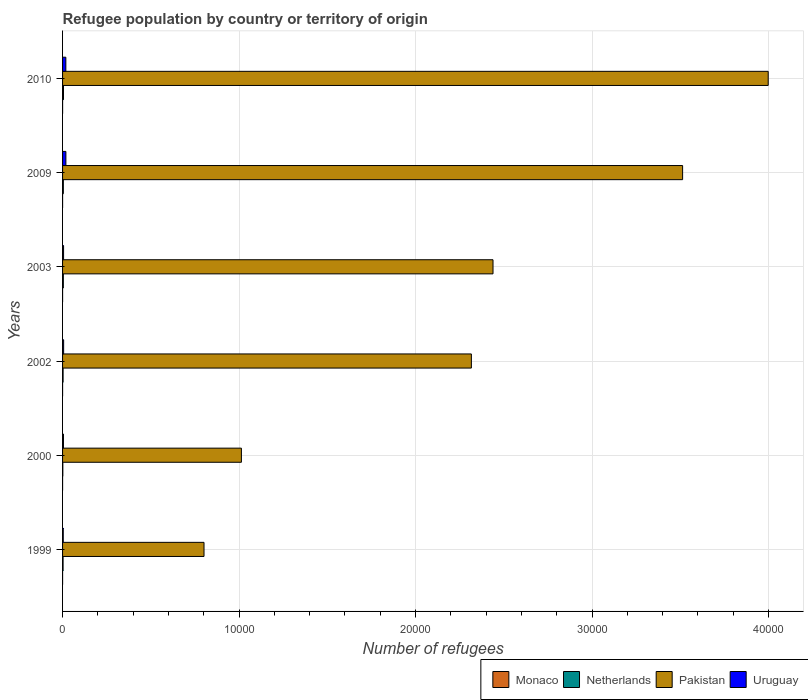How many different coloured bars are there?
Your response must be concise. 4. Are the number of bars per tick equal to the number of legend labels?
Offer a terse response. Yes. How many bars are there on the 6th tick from the top?
Provide a short and direct response. 4. What is the label of the 5th group of bars from the top?
Provide a succinct answer. 2000. What is the number of refugees in Uruguay in 2000?
Give a very brief answer. 51. Across all years, what is the minimum number of refugees in Monaco?
Provide a succinct answer. 1. In which year was the number of refugees in Pakistan maximum?
Ensure brevity in your answer.  2010. What is the difference between the number of refugees in Monaco in 1999 and that in 2000?
Keep it short and to the point. 0. What is the difference between the number of refugees in Monaco in 2000 and the number of refugees in Uruguay in 1999?
Keep it short and to the point. -38. What is the average number of refugees in Uruguay per year?
Offer a terse response. 97. In the year 2010, what is the difference between the number of refugees in Monaco and number of refugees in Netherlands?
Keep it short and to the point. -51. In how many years, is the number of refugees in Monaco greater than 18000 ?
Provide a short and direct response. 0. Is the difference between the number of refugees in Monaco in 2002 and 2009 greater than the difference between the number of refugees in Netherlands in 2002 and 2009?
Provide a succinct answer. Yes. What is the difference between the highest and the second highest number of refugees in Monaco?
Keep it short and to the point. 1. What is the difference between the highest and the lowest number of refugees in Uruguay?
Your answer should be very brief. 149. What does the 1st bar from the bottom in 2000 represents?
Your response must be concise. Monaco. Is it the case that in every year, the sum of the number of refugees in Monaco and number of refugees in Netherlands is greater than the number of refugees in Pakistan?
Your response must be concise. No. How many bars are there?
Make the answer very short. 24. Are the values on the major ticks of X-axis written in scientific E-notation?
Your answer should be very brief. No. Does the graph contain any zero values?
Your answer should be compact. No. Does the graph contain grids?
Keep it short and to the point. Yes. Where does the legend appear in the graph?
Ensure brevity in your answer.  Bottom right. How many legend labels are there?
Make the answer very short. 4. What is the title of the graph?
Your answer should be compact. Refugee population by country or territory of origin. Does "Jordan" appear as one of the legend labels in the graph?
Offer a very short reply. No. What is the label or title of the X-axis?
Offer a very short reply. Number of refugees. What is the Number of refugees in Netherlands in 1999?
Offer a very short reply. 29. What is the Number of refugees in Pakistan in 1999?
Make the answer very short. 8015. What is the Number of refugees in Netherlands in 2000?
Keep it short and to the point. 15. What is the Number of refugees of Pakistan in 2000?
Make the answer very short. 1.01e+04. What is the Number of refugees of Monaco in 2002?
Your answer should be very brief. 1. What is the Number of refugees in Netherlands in 2002?
Provide a succinct answer. 30. What is the Number of refugees in Pakistan in 2002?
Your response must be concise. 2.32e+04. What is the Number of refugees of Uruguay in 2002?
Your response must be concise. 61. What is the Number of refugees of Monaco in 2003?
Offer a terse response. 1. What is the Number of refugees of Pakistan in 2003?
Provide a succinct answer. 2.44e+04. What is the Number of refugees in Uruguay in 2003?
Ensure brevity in your answer.  57. What is the Number of refugees in Netherlands in 2009?
Make the answer very short. 44. What is the Number of refugees of Pakistan in 2009?
Your answer should be very brief. 3.51e+04. What is the Number of refugees in Uruguay in 2009?
Ensure brevity in your answer.  188. What is the Number of refugees in Netherlands in 2010?
Provide a succinct answer. 53. What is the Number of refugees in Pakistan in 2010?
Ensure brevity in your answer.  4.00e+04. What is the Number of refugees of Uruguay in 2010?
Your answer should be very brief. 186. Across all years, what is the maximum Number of refugees in Monaco?
Your answer should be compact. 2. Across all years, what is the maximum Number of refugees of Netherlands?
Your answer should be compact. 53. Across all years, what is the maximum Number of refugees of Pakistan?
Provide a succinct answer. 4.00e+04. Across all years, what is the maximum Number of refugees of Uruguay?
Provide a short and direct response. 188. Across all years, what is the minimum Number of refugees of Pakistan?
Your answer should be compact. 8015. Across all years, what is the minimum Number of refugees of Uruguay?
Provide a short and direct response. 39. What is the total Number of refugees of Monaco in the graph?
Your answer should be very brief. 7. What is the total Number of refugees in Netherlands in the graph?
Make the answer very short. 215. What is the total Number of refugees of Pakistan in the graph?
Ensure brevity in your answer.  1.41e+05. What is the total Number of refugees of Uruguay in the graph?
Keep it short and to the point. 582. What is the difference between the Number of refugees of Monaco in 1999 and that in 2000?
Offer a very short reply. 0. What is the difference between the Number of refugees of Netherlands in 1999 and that in 2000?
Offer a terse response. 14. What is the difference between the Number of refugees in Pakistan in 1999 and that in 2000?
Provide a short and direct response. -2118. What is the difference between the Number of refugees of Netherlands in 1999 and that in 2002?
Offer a terse response. -1. What is the difference between the Number of refugees in Pakistan in 1999 and that in 2002?
Keep it short and to the point. -1.51e+04. What is the difference between the Number of refugees in Monaco in 1999 and that in 2003?
Ensure brevity in your answer.  0. What is the difference between the Number of refugees of Netherlands in 1999 and that in 2003?
Keep it short and to the point. -15. What is the difference between the Number of refugees in Pakistan in 1999 and that in 2003?
Ensure brevity in your answer.  -1.64e+04. What is the difference between the Number of refugees of Uruguay in 1999 and that in 2003?
Your answer should be very brief. -18. What is the difference between the Number of refugees of Monaco in 1999 and that in 2009?
Keep it short and to the point. 0. What is the difference between the Number of refugees in Pakistan in 1999 and that in 2009?
Your response must be concise. -2.71e+04. What is the difference between the Number of refugees of Uruguay in 1999 and that in 2009?
Ensure brevity in your answer.  -149. What is the difference between the Number of refugees in Netherlands in 1999 and that in 2010?
Ensure brevity in your answer.  -24. What is the difference between the Number of refugees of Pakistan in 1999 and that in 2010?
Provide a succinct answer. -3.20e+04. What is the difference between the Number of refugees in Uruguay in 1999 and that in 2010?
Offer a terse response. -147. What is the difference between the Number of refugees in Monaco in 2000 and that in 2002?
Your answer should be very brief. 0. What is the difference between the Number of refugees in Pakistan in 2000 and that in 2002?
Offer a terse response. -1.30e+04. What is the difference between the Number of refugees in Monaco in 2000 and that in 2003?
Ensure brevity in your answer.  0. What is the difference between the Number of refugees of Pakistan in 2000 and that in 2003?
Provide a short and direct response. -1.43e+04. What is the difference between the Number of refugees of Monaco in 2000 and that in 2009?
Your response must be concise. 0. What is the difference between the Number of refugees of Pakistan in 2000 and that in 2009?
Give a very brief answer. -2.50e+04. What is the difference between the Number of refugees of Uruguay in 2000 and that in 2009?
Offer a very short reply. -137. What is the difference between the Number of refugees in Netherlands in 2000 and that in 2010?
Make the answer very short. -38. What is the difference between the Number of refugees of Pakistan in 2000 and that in 2010?
Provide a succinct answer. -2.98e+04. What is the difference between the Number of refugees of Uruguay in 2000 and that in 2010?
Keep it short and to the point. -135. What is the difference between the Number of refugees in Pakistan in 2002 and that in 2003?
Provide a succinct answer. -1226. What is the difference between the Number of refugees in Uruguay in 2002 and that in 2003?
Make the answer very short. 4. What is the difference between the Number of refugees in Netherlands in 2002 and that in 2009?
Provide a short and direct response. -14. What is the difference between the Number of refugees in Pakistan in 2002 and that in 2009?
Keep it short and to the point. -1.20e+04. What is the difference between the Number of refugees of Uruguay in 2002 and that in 2009?
Ensure brevity in your answer.  -127. What is the difference between the Number of refugees in Pakistan in 2002 and that in 2010?
Offer a terse response. -1.68e+04. What is the difference between the Number of refugees of Uruguay in 2002 and that in 2010?
Make the answer very short. -125. What is the difference between the Number of refugees of Monaco in 2003 and that in 2009?
Your answer should be compact. 0. What is the difference between the Number of refugees in Pakistan in 2003 and that in 2009?
Keep it short and to the point. -1.07e+04. What is the difference between the Number of refugees in Uruguay in 2003 and that in 2009?
Provide a succinct answer. -131. What is the difference between the Number of refugees of Monaco in 2003 and that in 2010?
Your answer should be very brief. -1. What is the difference between the Number of refugees in Pakistan in 2003 and that in 2010?
Ensure brevity in your answer.  -1.56e+04. What is the difference between the Number of refugees in Uruguay in 2003 and that in 2010?
Ensure brevity in your answer.  -129. What is the difference between the Number of refugees of Monaco in 2009 and that in 2010?
Provide a succinct answer. -1. What is the difference between the Number of refugees in Netherlands in 2009 and that in 2010?
Provide a short and direct response. -9. What is the difference between the Number of refugees of Pakistan in 2009 and that in 2010?
Your answer should be very brief. -4850. What is the difference between the Number of refugees in Monaco in 1999 and the Number of refugees in Netherlands in 2000?
Your answer should be compact. -14. What is the difference between the Number of refugees in Monaco in 1999 and the Number of refugees in Pakistan in 2000?
Ensure brevity in your answer.  -1.01e+04. What is the difference between the Number of refugees of Netherlands in 1999 and the Number of refugees of Pakistan in 2000?
Your response must be concise. -1.01e+04. What is the difference between the Number of refugees in Pakistan in 1999 and the Number of refugees in Uruguay in 2000?
Give a very brief answer. 7964. What is the difference between the Number of refugees in Monaco in 1999 and the Number of refugees in Pakistan in 2002?
Give a very brief answer. -2.32e+04. What is the difference between the Number of refugees of Monaco in 1999 and the Number of refugees of Uruguay in 2002?
Provide a succinct answer. -60. What is the difference between the Number of refugees of Netherlands in 1999 and the Number of refugees of Pakistan in 2002?
Your response must be concise. -2.31e+04. What is the difference between the Number of refugees of Netherlands in 1999 and the Number of refugees of Uruguay in 2002?
Offer a very short reply. -32. What is the difference between the Number of refugees of Pakistan in 1999 and the Number of refugees of Uruguay in 2002?
Provide a succinct answer. 7954. What is the difference between the Number of refugees of Monaco in 1999 and the Number of refugees of Netherlands in 2003?
Provide a succinct answer. -43. What is the difference between the Number of refugees in Monaco in 1999 and the Number of refugees in Pakistan in 2003?
Your response must be concise. -2.44e+04. What is the difference between the Number of refugees in Monaco in 1999 and the Number of refugees in Uruguay in 2003?
Your answer should be compact. -56. What is the difference between the Number of refugees of Netherlands in 1999 and the Number of refugees of Pakistan in 2003?
Offer a very short reply. -2.44e+04. What is the difference between the Number of refugees in Netherlands in 1999 and the Number of refugees in Uruguay in 2003?
Ensure brevity in your answer.  -28. What is the difference between the Number of refugees of Pakistan in 1999 and the Number of refugees of Uruguay in 2003?
Your answer should be very brief. 7958. What is the difference between the Number of refugees in Monaco in 1999 and the Number of refugees in Netherlands in 2009?
Provide a short and direct response. -43. What is the difference between the Number of refugees of Monaco in 1999 and the Number of refugees of Pakistan in 2009?
Ensure brevity in your answer.  -3.51e+04. What is the difference between the Number of refugees in Monaco in 1999 and the Number of refugees in Uruguay in 2009?
Provide a succinct answer. -187. What is the difference between the Number of refugees in Netherlands in 1999 and the Number of refugees in Pakistan in 2009?
Provide a succinct answer. -3.51e+04. What is the difference between the Number of refugees in Netherlands in 1999 and the Number of refugees in Uruguay in 2009?
Your response must be concise. -159. What is the difference between the Number of refugees in Pakistan in 1999 and the Number of refugees in Uruguay in 2009?
Keep it short and to the point. 7827. What is the difference between the Number of refugees of Monaco in 1999 and the Number of refugees of Netherlands in 2010?
Give a very brief answer. -52. What is the difference between the Number of refugees in Monaco in 1999 and the Number of refugees in Pakistan in 2010?
Your answer should be compact. -4.00e+04. What is the difference between the Number of refugees of Monaco in 1999 and the Number of refugees of Uruguay in 2010?
Offer a terse response. -185. What is the difference between the Number of refugees in Netherlands in 1999 and the Number of refugees in Pakistan in 2010?
Ensure brevity in your answer.  -4.00e+04. What is the difference between the Number of refugees in Netherlands in 1999 and the Number of refugees in Uruguay in 2010?
Offer a terse response. -157. What is the difference between the Number of refugees of Pakistan in 1999 and the Number of refugees of Uruguay in 2010?
Ensure brevity in your answer.  7829. What is the difference between the Number of refugees of Monaco in 2000 and the Number of refugees of Pakistan in 2002?
Offer a terse response. -2.32e+04. What is the difference between the Number of refugees in Monaco in 2000 and the Number of refugees in Uruguay in 2002?
Your response must be concise. -60. What is the difference between the Number of refugees of Netherlands in 2000 and the Number of refugees of Pakistan in 2002?
Keep it short and to the point. -2.31e+04. What is the difference between the Number of refugees of Netherlands in 2000 and the Number of refugees of Uruguay in 2002?
Offer a terse response. -46. What is the difference between the Number of refugees of Pakistan in 2000 and the Number of refugees of Uruguay in 2002?
Ensure brevity in your answer.  1.01e+04. What is the difference between the Number of refugees of Monaco in 2000 and the Number of refugees of Netherlands in 2003?
Provide a succinct answer. -43. What is the difference between the Number of refugees of Monaco in 2000 and the Number of refugees of Pakistan in 2003?
Ensure brevity in your answer.  -2.44e+04. What is the difference between the Number of refugees in Monaco in 2000 and the Number of refugees in Uruguay in 2003?
Ensure brevity in your answer.  -56. What is the difference between the Number of refugees in Netherlands in 2000 and the Number of refugees in Pakistan in 2003?
Provide a succinct answer. -2.44e+04. What is the difference between the Number of refugees in Netherlands in 2000 and the Number of refugees in Uruguay in 2003?
Your answer should be compact. -42. What is the difference between the Number of refugees of Pakistan in 2000 and the Number of refugees of Uruguay in 2003?
Ensure brevity in your answer.  1.01e+04. What is the difference between the Number of refugees in Monaco in 2000 and the Number of refugees in Netherlands in 2009?
Make the answer very short. -43. What is the difference between the Number of refugees of Monaco in 2000 and the Number of refugees of Pakistan in 2009?
Make the answer very short. -3.51e+04. What is the difference between the Number of refugees of Monaco in 2000 and the Number of refugees of Uruguay in 2009?
Keep it short and to the point. -187. What is the difference between the Number of refugees in Netherlands in 2000 and the Number of refugees in Pakistan in 2009?
Offer a very short reply. -3.51e+04. What is the difference between the Number of refugees of Netherlands in 2000 and the Number of refugees of Uruguay in 2009?
Make the answer very short. -173. What is the difference between the Number of refugees of Pakistan in 2000 and the Number of refugees of Uruguay in 2009?
Keep it short and to the point. 9945. What is the difference between the Number of refugees of Monaco in 2000 and the Number of refugees of Netherlands in 2010?
Offer a very short reply. -52. What is the difference between the Number of refugees in Monaco in 2000 and the Number of refugees in Pakistan in 2010?
Your answer should be compact. -4.00e+04. What is the difference between the Number of refugees in Monaco in 2000 and the Number of refugees in Uruguay in 2010?
Your answer should be compact. -185. What is the difference between the Number of refugees in Netherlands in 2000 and the Number of refugees in Pakistan in 2010?
Offer a very short reply. -4.00e+04. What is the difference between the Number of refugees of Netherlands in 2000 and the Number of refugees of Uruguay in 2010?
Offer a terse response. -171. What is the difference between the Number of refugees of Pakistan in 2000 and the Number of refugees of Uruguay in 2010?
Offer a terse response. 9947. What is the difference between the Number of refugees of Monaco in 2002 and the Number of refugees of Netherlands in 2003?
Your answer should be very brief. -43. What is the difference between the Number of refugees of Monaco in 2002 and the Number of refugees of Pakistan in 2003?
Your response must be concise. -2.44e+04. What is the difference between the Number of refugees in Monaco in 2002 and the Number of refugees in Uruguay in 2003?
Your answer should be very brief. -56. What is the difference between the Number of refugees in Netherlands in 2002 and the Number of refugees in Pakistan in 2003?
Keep it short and to the point. -2.44e+04. What is the difference between the Number of refugees of Pakistan in 2002 and the Number of refugees of Uruguay in 2003?
Make the answer very short. 2.31e+04. What is the difference between the Number of refugees of Monaco in 2002 and the Number of refugees of Netherlands in 2009?
Your response must be concise. -43. What is the difference between the Number of refugees in Monaco in 2002 and the Number of refugees in Pakistan in 2009?
Offer a terse response. -3.51e+04. What is the difference between the Number of refugees of Monaco in 2002 and the Number of refugees of Uruguay in 2009?
Offer a terse response. -187. What is the difference between the Number of refugees in Netherlands in 2002 and the Number of refugees in Pakistan in 2009?
Make the answer very short. -3.51e+04. What is the difference between the Number of refugees of Netherlands in 2002 and the Number of refugees of Uruguay in 2009?
Your answer should be compact. -158. What is the difference between the Number of refugees of Pakistan in 2002 and the Number of refugees of Uruguay in 2009?
Give a very brief answer. 2.30e+04. What is the difference between the Number of refugees of Monaco in 2002 and the Number of refugees of Netherlands in 2010?
Offer a terse response. -52. What is the difference between the Number of refugees of Monaco in 2002 and the Number of refugees of Pakistan in 2010?
Offer a very short reply. -4.00e+04. What is the difference between the Number of refugees in Monaco in 2002 and the Number of refugees in Uruguay in 2010?
Keep it short and to the point. -185. What is the difference between the Number of refugees of Netherlands in 2002 and the Number of refugees of Pakistan in 2010?
Offer a very short reply. -4.00e+04. What is the difference between the Number of refugees of Netherlands in 2002 and the Number of refugees of Uruguay in 2010?
Your response must be concise. -156. What is the difference between the Number of refugees of Pakistan in 2002 and the Number of refugees of Uruguay in 2010?
Your response must be concise. 2.30e+04. What is the difference between the Number of refugees of Monaco in 2003 and the Number of refugees of Netherlands in 2009?
Your answer should be very brief. -43. What is the difference between the Number of refugees of Monaco in 2003 and the Number of refugees of Pakistan in 2009?
Make the answer very short. -3.51e+04. What is the difference between the Number of refugees in Monaco in 2003 and the Number of refugees in Uruguay in 2009?
Make the answer very short. -187. What is the difference between the Number of refugees of Netherlands in 2003 and the Number of refugees of Pakistan in 2009?
Ensure brevity in your answer.  -3.51e+04. What is the difference between the Number of refugees in Netherlands in 2003 and the Number of refugees in Uruguay in 2009?
Make the answer very short. -144. What is the difference between the Number of refugees in Pakistan in 2003 and the Number of refugees in Uruguay in 2009?
Ensure brevity in your answer.  2.42e+04. What is the difference between the Number of refugees in Monaco in 2003 and the Number of refugees in Netherlands in 2010?
Ensure brevity in your answer.  -52. What is the difference between the Number of refugees of Monaco in 2003 and the Number of refugees of Pakistan in 2010?
Give a very brief answer. -4.00e+04. What is the difference between the Number of refugees of Monaco in 2003 and the Number of refugees of Uruguay in 2010?
Provide a short and direct response. -185. What is the difference between the Number of refugees in Netherlands in 2003 and the Number of refugees in Pakistan in 2010?
Your answer should be very brief. -3.99e+04. What is the difference between the Number of refugees of Netherlands in 2003 and the Number of refugees of Uruguay in 2010?
Your answer should be very brief. -142. What is the difference between the Number of refugees in Pakistan in 2003 and the Number of refugees in Uruguay in 2010?
Provide a succinct answer. 2.42e+04. What is the difference between the Number of refugees in Monaco in 2009 and the Number of refugees in Netherlands in 2010?
Offer a very short reply. -52. What is the difference between the Number of refugees of Monaco in 2009 and the Number of refugees of Pakistan in 2010?
Offer a terse response. -4.00e+04. What is the difference between the Number of refugees in Monaco in 2009 and the Number of refugees in Uruguay in 2010?
Provide a short and direct response. -185. What is the difference between the Number of refugees in Netherlands in 2009 and the Number of refugees in Pakistan in 2010?
Your answer should be very brief. -3.99e+04. What is the difference between the Number of refugees in Netherlands in 2009 and the Number of refugees in Uruguay in 2010?
Your answer should be compact. -142. What is the difference between the Number of refugees in Pakistan in 2009 and the Number of refugees in Uruguay in 2010?
Give a very brief answer. 3.49e+04. What is the average Number of refugees of Monaco per year?
Your response must be concise. 1.17. What is the average Number of refugees in Netherlands per year?
Offer a very short reply. 35.83. What is the average Number of refugees in Pakistan per year?
Provide a succinct answer. 2.35e+04. What is the average Number of refugees of Uruguay per year?
Your answer should be very brief. 97. In the year 1999, what is the difference between the Number of refugees in Monaco and Number of refugees in Netherlands?
Your answer should be compact. -28. In the year 1999, what is the difference between the Number of refugees in Monaco and Number of refugees in Pakistan?
Your answer should be compact. -8014. In the year 1999, what is the difference between the Number of refugees in Monaco and Number of refugees in Uruguay?
Keep it short and to the point. -38. In the year 1999, what is the difference between the Number of refugees in Netherlands and Number of refugees in Pakistan?
Your answer should be very brief. -7986. In the year 1999, what is the difference between the Number of refugees of Netherlands and Number of refugees of Uruguay?
Offer a very short reply. -10. In the year 1999, what is the difference between the Number of refugees in Pakistan and Number of refugees in Uruguay?
Offer a very short reply. 7976. In the year 2000, what is the difference between the Number of refugees of Monaco and Number of refugees of Netherlands?
Ensure brevity in your answer.  -14. In the year 2000, what is the difference between the Number of refugees in Monaco and Number of refugees in Pakistan?
Your answer should be compact. -1.01e+04. In the year 2000, what is the difference between the Number of refugees in Netherlands and Number of refugees in Pakistan?
Your response must be concise. -1.01e+04. In the year 2000, what is the difference between the Number of refugees in Netherlands and Number of refugees in Uruguay?
Your response must be concise. -36. In the year 2000, what is the difference between the Number of refugees of Pakistan and Number of refugees of Uruguay?
Keep it short and to the point. 1.01e+04. In the year 2002, what is the difference between the Number of refugees of Monaco and Number of refugees of Netherlands?
Give a very brief answer. -29. In the year 2002, what is the difference between the Number of refugees of Monaco and Number of refugees of Pakistan?
Make the answer very short. -2.32e+04. In the year 2002, what is the difference between the Number of refugees of Monaco and Number of refugees of Uruguay?
Your response must be concise. -60. In the year 2002, what is the difference between the Number of refugees of Netherlands and Number of refugees of Pakistan?
Your response must be concise. -2.31e+04. In the year 2002, what is the difference between the Number of refugees in Netherlands and Number of refugees in Uruguay?
Keep it short and to the point. -31. In the year 2002, what is the difference between the Number of refugees of Pakistan and Number of refugees of Uruguay?
Offer a terse response. 2.31e+04. In the year 2003, what is the difference between the Number of refugees of Monaco and Number of refugees of Netherlands?
Ensure brevity in your answer.  -43. In the year 2003, what is the difference between the Number of refugees in Monaco and Number of refugees in Pakistan?
Give a very brief answer. -2.44e+04. In the year 2003, what is the difference between the Number of refugees of Monaco and Number of refugees of Uruguay?
Give a very brief answer. -56. In the year 2003, what is the difference between the Number of refugees in Netherlands and Number of refugees in Pakistan?
Give a very brief answer. -2.43e+04. In the year 2003, what is the difference between the Number of refugees in Netherlands and Number of refugees in Uruguay?
Offer a terse response. -13. In the year 2003, what is the difference between the Number of refugees of Pakistan and Number of refugees of Uruguay?
Make the answer very short. 2.43e+04. In the year 2009, what is the difference between the Number of refugees of Monaco and Number of refugees of Netherlands?
Ensure brevity in your answer.  -43. In the year 2009, what is the difference between the Number of refugees in Monaco and Number of refugees in Pakistan?
Keep it short and to the point. -3.51e+04. In the year 2009, what is the difference between the Number of refugees in Monaco and Number of refugees in Uruguay?
Keep it short and to the point. -187. In the year 2009, what is the difference between the Number of refugees of Netherlands and Number of refugees of Pakistan?
Your response must be concise. -3.51e+04. In the year 2009, what is the difference between the Number of refugees of Netherlands and Number of refugees of Uruguay?
Give a very brief answer. -144. In the year 2009, what is the difference between the Number of refugees in Pakistan and Number of refugees in Uruguay?
Provide a succinct answer. 3.49e+04. In the year 2010, what is the difference between the Number of refugees in Monaco and Number of refugees in Netherlands?
Offer a very short reply. -51. In the year 2010, what is the difference between the Number of refugees of Monaco and Number of refugees of Pakistan?
Offer a very short reply. -4.00e+04. In the year 2010, what is the difference between the Number of refugees of Monaco and Number of refugees of Uruguay?
Your answer should be very brief. -184. In the year 2010, what is the difference between the Number of refugees of Netherlands and Number of refugees of Pakistan?
Give a very brief answer. -3.99e+04. In the year 2010, what is the difference between the Number of refugees of Netherlands and Number of refugees of Uruguay?
Provide a succinct answer. -133. In the year 2010, what is the difference between the Number of refugees of Pakistan and Number of refugees of Uruguay?
Offer a very short reply. 3.98e+04. What is the ratio of the Number of refugees of Netherlands in 1999 to that in 2000?
Give a very brief answer. 1.93. What is the ratio of the Number of refugees of Pakistan in 1999 to that in 2000?
Keep it short and to the point. 0.79. What is the ratio of the Number of refugees of Uruguay in 1999 to that in 2000?
Your answer should be compact. 0.76. What is the ratio of the Number of refugees of Netherlands in 1999 to that in 2002?
Offer a very short reply. 0.97. What is the ratio of the Number of refugees of Pakistan in 1999 to that in 2002?
Give a very brief answer. 0.35. What is the ratio of the Number of refugees of Uruguay in 1999 to that in 2002?
Make the answer very short. 0.64. What is the ratio of the Number of refugees in Netherlands in 1999 to that in 2003?
Provide a succinct answer. 0.66. What is the ratio of the Number of refugees in Pakistan in 1999 to that in 2003?
Your answer should be very brief. 0.33. What is the ratio of the Number of refugees of Uruguay in 1999 to that in 2003?
Provide a succinct answer. 0.68. What is the ratio of the Number of refugees in Netherlands in 1999 to that in 2009?
Keep it short and to the point. 0.66. What is the ratio of the Number of refugees in Pakistan in 1999 to that in 2009?
Offer a terse response. 0.23. What is the ratio of the Number of refugees in Uruguay in 1999 to that in 2009?
Your answer should be compact. 0.21. What is the ratio of the Number of refugees of Netherlands in 1999 to that in 2010?
Make the answer very short. 0.55. What is the ratio of the Number of refugees in Pakistan in 1999 to that in 2010?
Your answer should be very brief. 0.2. What is the ratio of the Number of refugees in Uruguay in 1999 to that in 2010?
Ensure brevity in your answer.  0.21. What is the ratio of the Number of refugees of Netherlands in 2000 to that in 2002?
Your answer should be compact. 0.5. What is the ratio of the Number of refugees in Pakistan in 2000 to that in 2002?
Offer a very short reply. 0.44. What is the ratio of the Number of refugees of Uruguay in 2000 to that in 2002?
Provide a succinct answer. 0.84. What is the ratio of the Number of refugees in Monaco in 2000 to that in 2003?
Your answer should be very brief. 1. What is the ratio of the Number of refugees in Netherlands in 2000 to that in 2003?
Ensure brevity in your answer.  0.34. What is the ratio of the Number of refugees of Pakistan in 2000 to that in 2003?
Ensure brevity in your answer.  0.42. What is the ratio of the Number of refugees in Uruguay in 2000 to that in 2003?
Offer a terse response. 0.89. What is the ratio of the Number of refugees of Monaco in 2000 to that in 2009?
Your answer should be compact. 1. What is the ratio of the Number of refugees in Netherlands in 2000 to that in 2009?
Offer a very short reply. 0.34. What is the ratio of the Number of refugees of Pakistan in 2000 to that in 2009?
Offer a terse response. 0.29. What is the ratio of the Number of refugees in Uruguay in 2000 to that in 2009?
Ensure brevity in your answer.  0.27. What is the ratio of the Number of refugees in Netherlands in 2000 to that in 2010?
Make the answer very short. 0.28. What is the ratio of the Number of refugees of Pakistan in 2000 to that in 2010?
Your answer should be compact. 0.25. What is the ratio of the Number of refugees of Uruguay in 2000 to that in 2010?
Provide a short and direct response. 0.27. What is the ratio of the Number of refugees of Monaco in 2002 to that in 2003?
Keep it short and to the point. 1. What is the ratio of the Number of refugees in Netherlands in 2002 to that in 2003?
Give a very brief answer. 0.68. What is the ratio of the Number of refugees in Pakistan in 2002 to that in 2003?
Give a very brief answer. 0.95. What is the ratio of the Number of refugees of Uruguay in 2002 to that in 2003?
Provide a short and direct response. 1.07. What is the ratio of the Number of refugees in Monaco in 2002 to that in 2009?
Your response must be concise. 1. What is the ratio of the Number of refugees of Netherlands in 2002 to that in 2009?
Ensure brevity in your answer.  0.68. What is the ratio of the Number of refugees in Pakistan in 2002 to that in 2009?
Your response must be concise. 0.66. What is the ratio of the Number of refugees of Uruguay in 2002 to that in 2009?
Give a very brief answer. 0.32. What is the ratio of the Number of refugees of Monaco in 2002 to that in 2010?
Offer a terse response. 0.5. What is the ratio of the Number of refugees of Netherlands in 2002 to that in 2010?
Keep it short and to the point. 0.57. What is the ratio of the Number of refugees of Pakistan in 2002 to that in 2010?
Make the answer very short. 0.58. What is the ratio of the Number of refugees of Uruguay in 2002 to that in 2010?
Your answer should be very brief. 0.33. What is the ratio of the Number of refugees of Monaco in 2003 to that in 2009?
Ensure brevity in your answer.  1. What is the ratio of the Number of refugees in Netherlands in 2003 to that in 2009?
Make the answer very short. 1. What is the ratio of the Number of refugees in Pakistan in 2003 to that in 2009?
Your answer should be compact. 0.69. What is the ratio of the Number of refugees in Uruguay in 2003 to that in 2009?
Give a very brief answer. 0.3. What is the ratio of the Number of refugees in Netherlands in 2003 to that in 2010?
Make the answer very short. 0.83. What is the ratio of the Number of refugees of Pakistan in 2003 to that in 2010?
Offer a terse response. 0.61. What is the ratio of the Number of refugees of Uruguay in 2003 to that in 2010?
Keep it short and to the point. 0.31. What is the ratio of the Number of refugees of Monaco in 2009 to that in 2010?
Make the answer very short. 0.5. What is the ratio of the Number of refugees of Netherlands in 2009 to that in 2010?
Provide a succinct answer. 0.83. What is the ratio of the Number of refugees of Pakistan in 2009 to that in 2010?
Give a very brief answer. 0.88. What is the ratio of the Number of refugees of Uruguay in 2009 to that in 2010?
Provide a short and direct response. 1.01. What is the difference between the highest and the second highest Number of refugees of Pakistan?
Keep it short and to the point. 4850. What is the difference between the highest and the second highest Number of refugees in Uruguay?
Your answer should be very brief. 2. What is the difference between the highest and the lowest Number of refugees in Pakistan?
Keep it short and to the point. 3.20e+04. What is the difference between the highest and the lowest Number of refugees in Uruguay?
Provide a short and direct response. 149. 